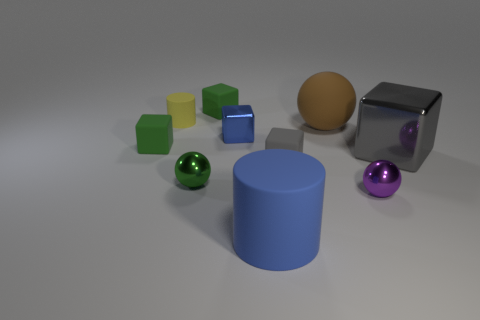What number of other objects are there of the same size as the blue block?
Your response must be concise. 6. Does the small green thing that is in front of the big shiny thing have the same material as the tiny object to the right of the large brown matte thing?
Keep it short and to the point. Yes. What size is the sphere that is left of the matte thing that is behind the yellow cylinder?
Offer a terse response. Small. Are there any small cylinders of the same color as the large metallic cube?
Offer a very short reply. No. There is a shiny sphere that is to the left of the brown rubber object; does it have the same color as the block that is behind the brown thing?
Ensure brevity in your answer.  Yes. There is a big gray thing; what shape is it?
Your answer should be very brief. Cube. There is a large gray cube; what number of big cylinders are behind it?
Your answer should be compact. 0. What number of big blue cylinders have the same material as the big gray thing?
Provide a short and direct response. 0. Does the thing that is on the left side of the small cylinder have the same material as the large blue thing?
Ensure brevity in your answer.  Yes. Is there a big rubber cylinder?
Provide a short and direct response. Yes. 